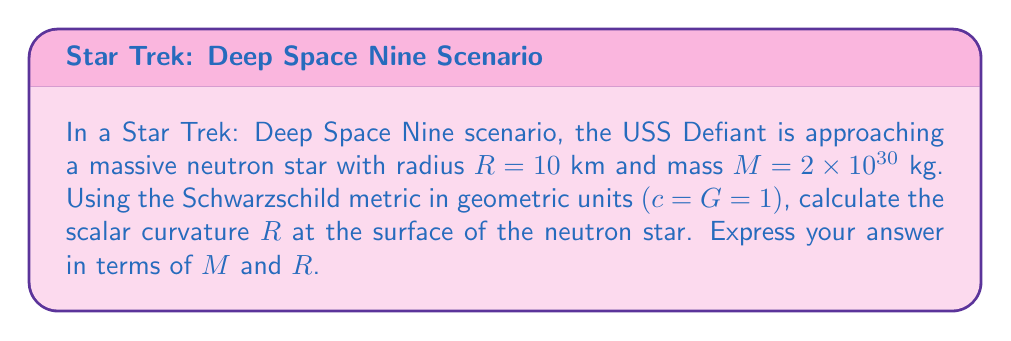Help me with this question. Let's approach this step-by-step:

1) The Schwarzschild metric in geometric units is given by:

   $$ds^2 = -\left(1-\frac{2M}{r}\right)dt^2 + \left(1-\frac{2M}{r}\right)^{-1}dr^2 + r^2(d\theta^2 + \sin^2\theta d\phi^2)$$

2) To calculate the scalar curvature, we need to first determine the Ricci tensor $R_{\mu\nu}$ and then contract it to get the scalar curvature $R$.

3) For the Schwarzschild metric, the non-zero components of the Ricci tensor are:

   $$R_{tt} = \frac{2M}{r^3}\left(1-\frac{2M}{r}\right)$$
   $$R_{rr} = -\frac{2M}{r^3}\left(1-\frac{2M}{r}\right)^{-1}$$
   $$R_{\theta\theta} = -2M/r$$
   $$R_{\phi\phi} = -2M\sin^2\theta/r$$

4) The scalar curvature is the contraction of the Ricci tensor:

   $$R = g^{\mu\nu}R_{\mu\nu}$$

5) For the Schwarzschild metric, this simplifies to:

   $$R = -g^{tt}R_{tt} + g^{rr}R_{rr} + g^{\theta\theta}R_{\theta\theta} + g^{\phi\phi}R_{\phi\phi}$$

6) Substituting the components:

   $$R = -\left(1-\frac{2M}{r}\right)^{-1}\frac{2M}{r^3}\left(1-\frac{2M}{r}\right) + \left(1-\frac{2M}{r}\right)\frac{2M}{r^3}\left(1-\frac{2M}{r}\right)^{-1} + \frac{1}{r^2}(-2M/r) + \frac{1}{r^2\sin^2\theta}(-2M\sin^2\theta/r)$$

7) Simplifying:

   $$R = -\frac{2M}{r^3} + \frac{2M}{r^3} - \frac{2M}{r^3} - \frac{2M}{r^3} = -\frac{4M}{r^3}$$

8) At the surface of the neutron star, $r = R$, so:

   $$R = -\frac{4M}{R^3}$$
Answer: $R = -\frac{4M}{R^3}$ 